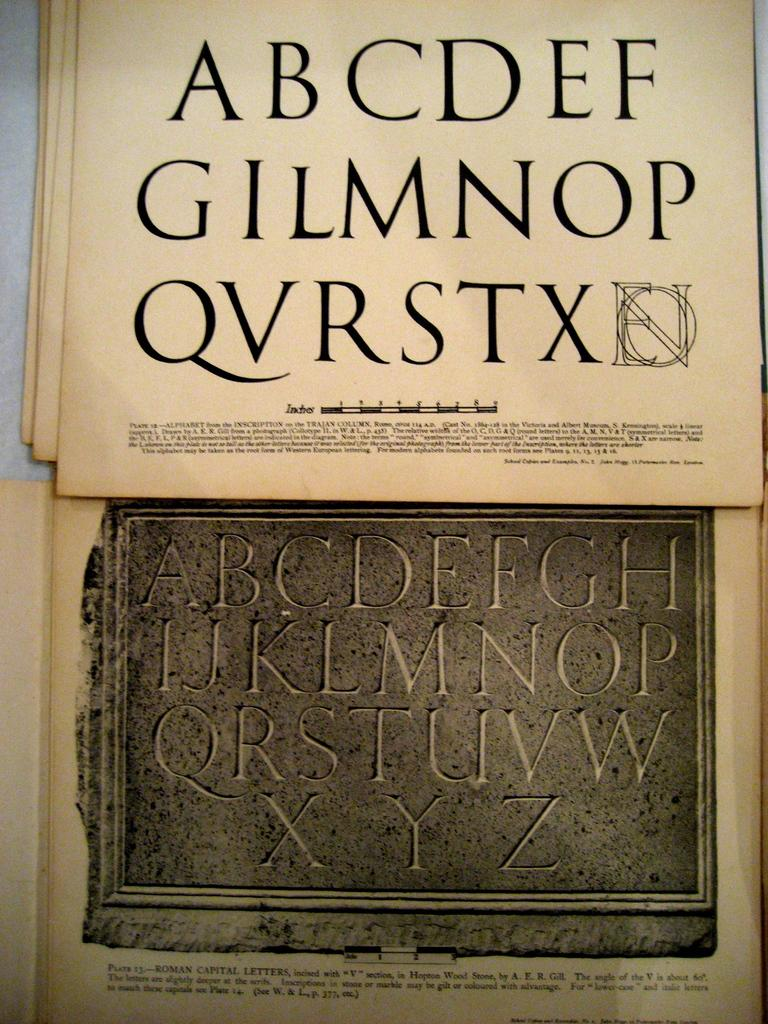Provide a one-sentence caption for the provided image. A sting of letters starting with A, B and C are printed on a paper. 